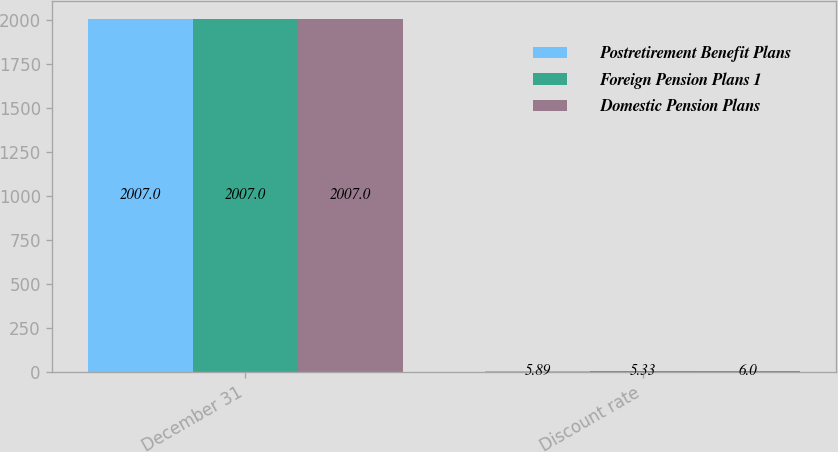Convert chart to OTSL. <chart><loc_0><loc_0><loc_500><loc_500><stacked_bar_chart><ecel><fcel>December 31<fcel>Discount rate<nl><fcel>Postretirement Benefit Plans<fcel>2007<fcel>5.89<nl><fcel>Foreign Pension Plans 1<fcel>2007<fcel>5.33<nl><fcel>Domestic Pension Plans<fcel>2007<fcel>6<nl></chart> 